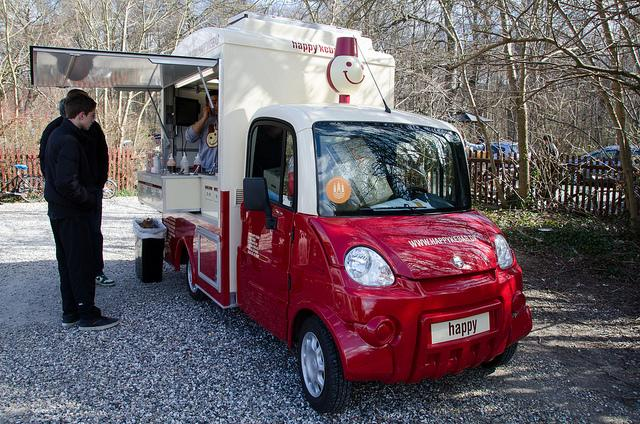Where could someone put their garbage? Please explain your reasoning. rubbish bin. People could put their garbage inside of the garbage bin on the left. 